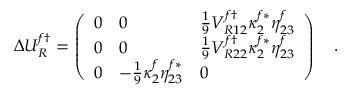Convert formula to latex. <formula><loc_0><loc_0><loc_500><loc_500>\Delta U _ { R } ^ { f \dagger } = \left ( \begin{array} { l l l } { 0 } & { 0 } & { { { \frac { 1 } { 9 } } V _ { R 1 2 } ^ { f \dagger } \kappa _ { 2 } ^ { f * } \eta _ { 2 3 } ^ { f } } } \\ { 0 } & { 0 } & { { { \frac { 1 } { 9 } } V _ { R 2 2 } ^ { f \dagger } \kappa _ { 2 } ^ { f * } \eta _ { 2 3 } ^ { f } } } \\ { 0 } & { { - { \frac { 1 } { 9 } } \kappa _ { 2 } ^ { f } \eta _ { 2 3 } ^ { f * } } } & { 0 } \end{array} \right ) .</formula> 